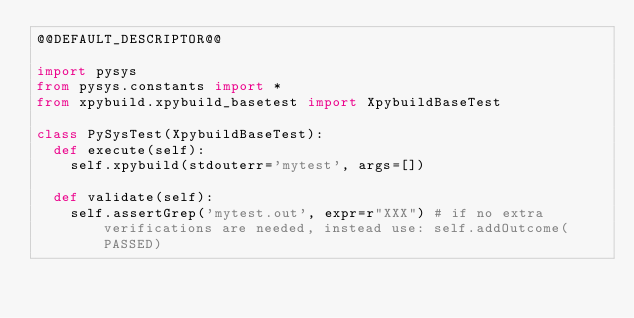<code> <loc_0><loc_0><loc_500><loc_500><_Python_>@@DEFAULT_DESCRIPTOR@@

import pysys
from pysys.constants import *
from xpybuild.xpybuild_basetest import XpybuildBaseTest

class PySysTest(XpybuildBaseTest):
	def execute(self):
		self.xpybuild(stdouterr='mytest', args=[])

	def validate(self):
		self.assertGrep('mytest.out', expr=r"XXX") # if no extra verifications are needed, instead use: self.addOutcome(PASSED)
</code> 